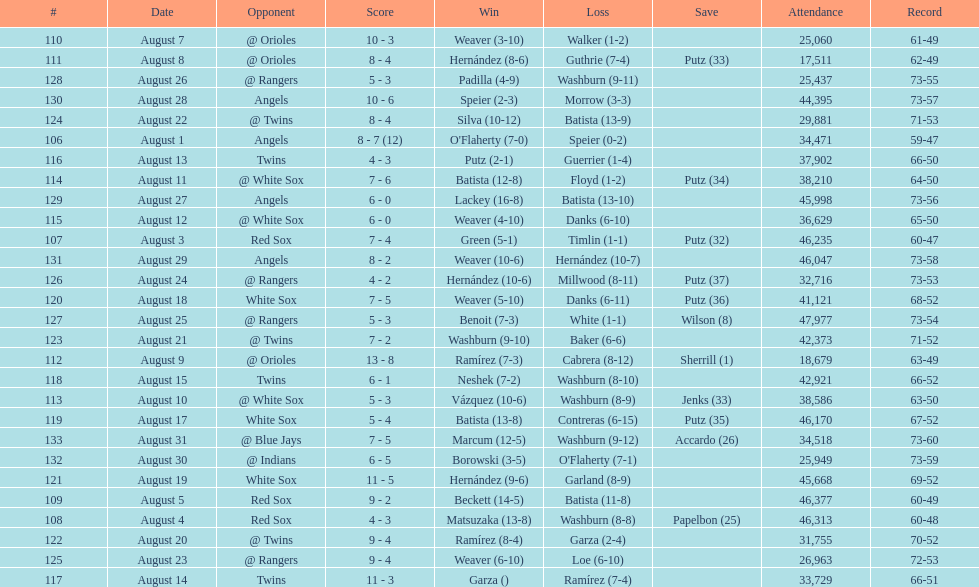Games above 30,000 in attendance 21. 